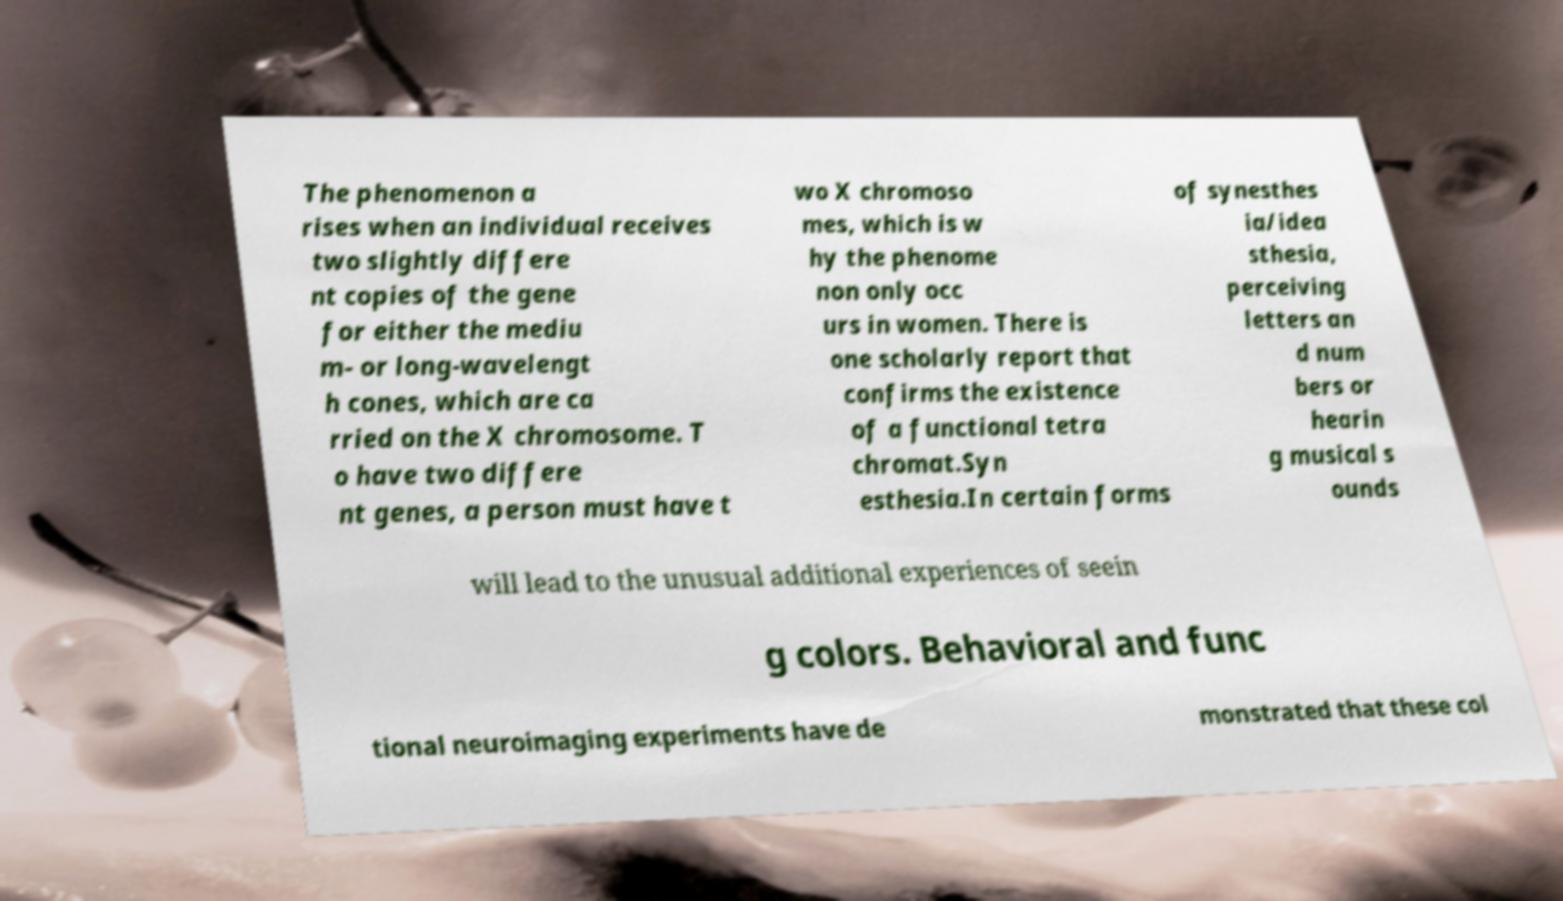There's text embedded in this image that I need extracted. Can you transcribe it verbatim? The phenomenon a rises when an individual receives two slightly differe nt copies of the gene for either the mediu m- or long-wavelengt h cones, which are ca rried on the X chromosome. T o have two differe nt genes, a person must have t wo X chromoso mes, which is w hy the phenome non only occ urs in women. There is one scholarly report that confirms the existence of a functional tetra chromat.Syn esthesia.In certain forms of synesthes ia/idea sthesia, perceiving letters an d num bers or hearin g musical s ounds will lead to the unusual additional experiences of seein g colors. Behavioral and func tional neuroimaging experiments have de monstrated that these col 